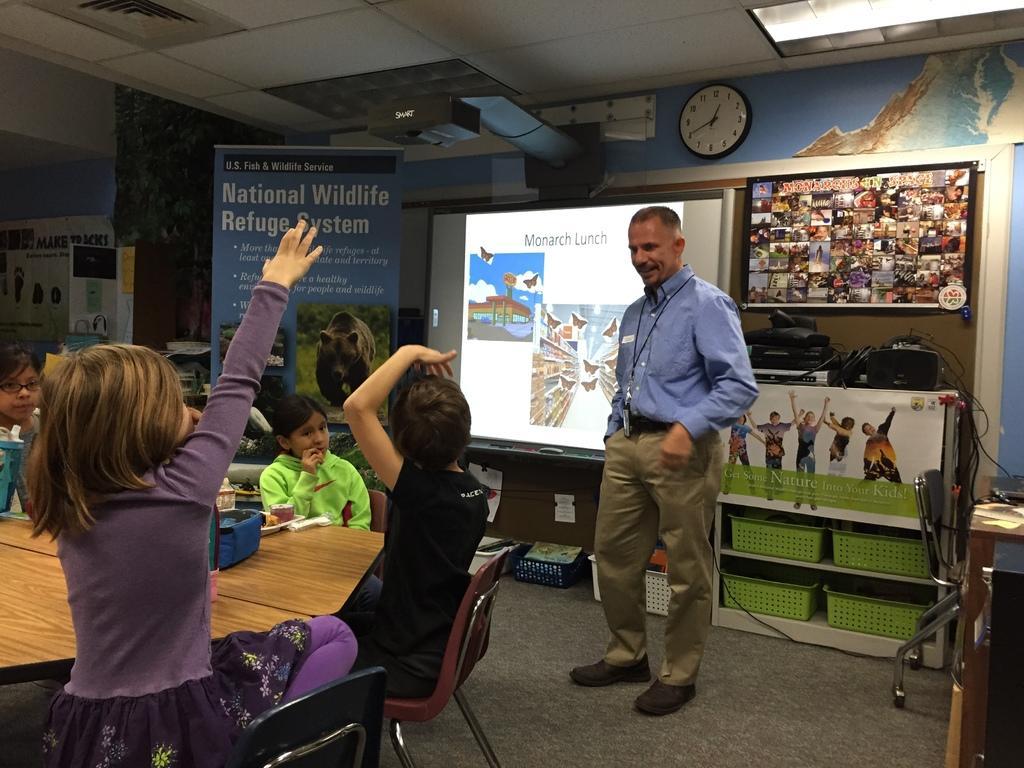How would you summarize this image in a sentence or two? In this image i can see a man standing wearing purple shirt and cream pant and shoe, there are few children sitting on a chair, the children standing here is wearing a purple dress, children sitting wearing a black t-shirt, a child sitting here wearing a green shirt there are few toys on the table, at the back ground i can see a blue color banner, a screen, a projector and a clock attached to a blue wall at the top i can see a light on the banner i can see few children there are few baskets in the rack. 